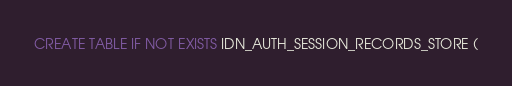<code> <loc_0><loc_0><loc_500><loc_500><_SQL_>CREATE TABLE IF NOT EXISTS IDN_AUTH_SESSION_RECORDS_STORE (</code> 